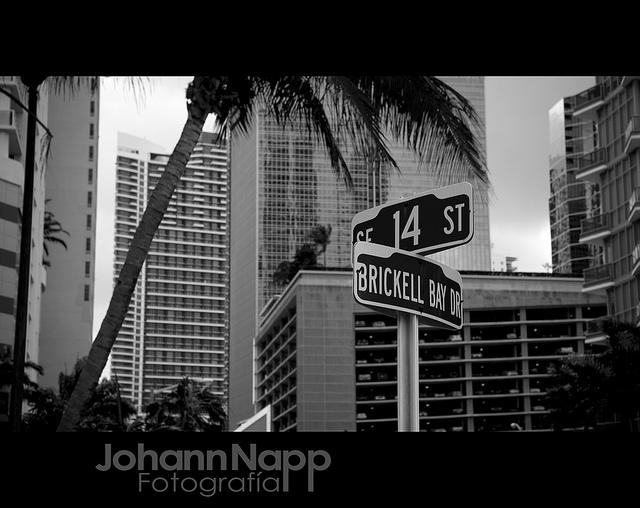Where is the name of the street?
Quick response, please. Brickell bay dr. What street number is this?
Short answer required. 14. Is this a city setting?
Keep it brief. Yes. What is the name of the Bay Drive?
Keep it brief. Brickell. Can you tell what flag is flying?
Quick response, please. No. 